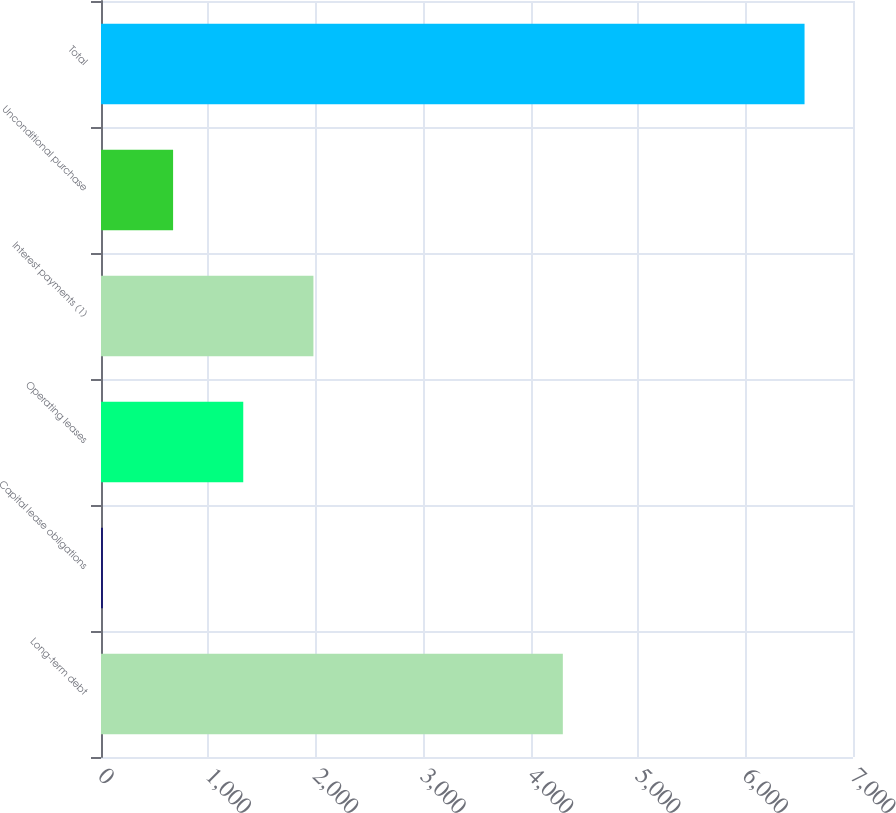Convert chart. <chart><loc_0><loc_0><loc_500><loc_500><bar_chart><fcel>Long-term debt<fcel>Capital lease obligations<fcel>Operating leases<fcel>Interest payments (1)<fcel>Unconditional purchase<fcel>Total<nl><fcel>4299<fcel>18<fcel>1324.2<fcel>1977.3<fcel>671.1<fcel>6549<nl></chart> 